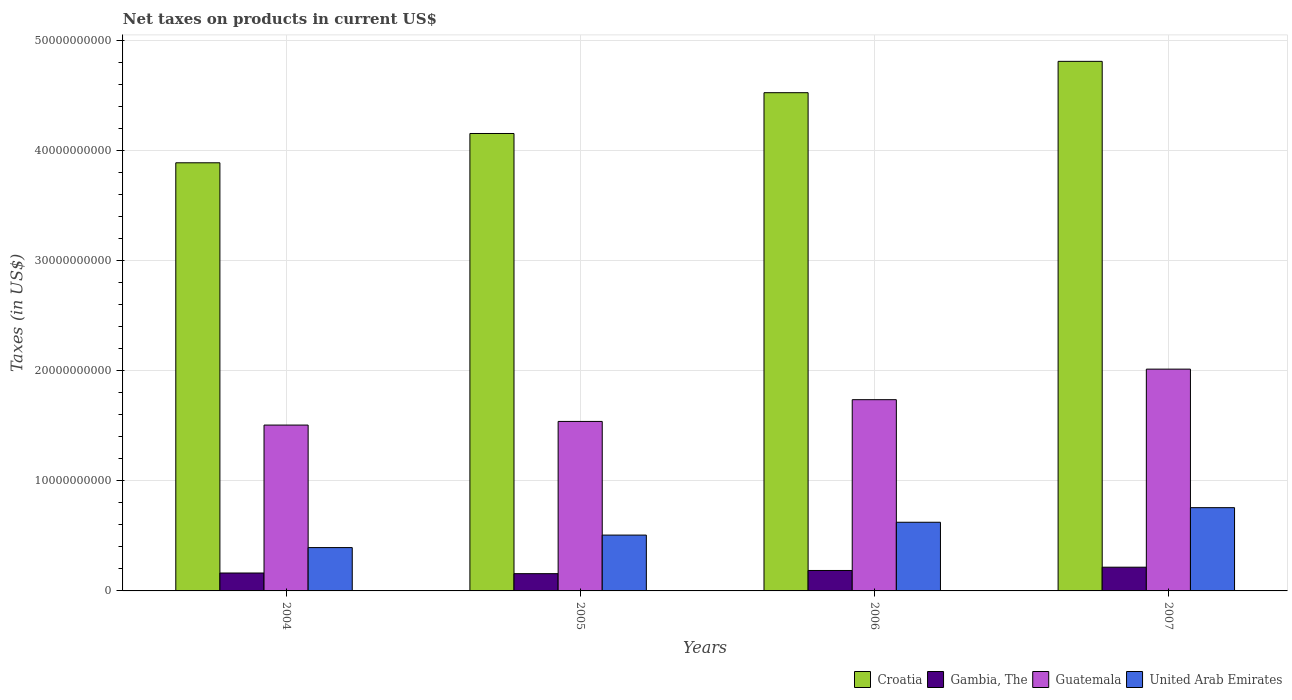How many groups of bars are there?
Offer a very short reply. 4. Are the number of bars per tick equal to the number of legend labels?
Keep it short and to the point. Yes. Are the number of bars on each tick of the X-axis equal?
Keep it short and to the point. Yes. How many bars are there on the 2nd tick from the right?
Provide a succinct answer. 4. What is the label of the 4th group of bars from the left?
Provide a short and direct response. 2007. In how many cases, is the number of bars for a given year not equal to the number of legend labels?
Make the answer very short. 0. What is the net taxes on products in Gambia, The in 2007?
Make the answer very short. 2.15e+09. Across all years, what is the maximum net taxes on products in Guatemala?
Make the answer very short. 2.01e+1. Across all years, what is the minimum net taxes on products in Croatia?
Offer a very short reply. 3.89e+1. In which year was the net taxes on products in Croatia maximum?
Your answer should be compact. 2007. What is the total net taxes on products in United Arab Emirates in the graph?
Keep it short and to the point. 2.28e+1. What is the difference between the net taxes on products in United Arab Emirates in 2004 and that in 2006?
Your answer should be compact. -2.30e+09. What is the difference between the net taxes on products in Croatia in 2006 and the net taxes on products in Guatemala in 2004?
Your answer should be compact. 3.02e+1. What is the average net taxes on products in United Arab Emirates per year?
Provide a short and direct response. 5.70e+09. In the year 2004, what is the difference between the net taxes on products in Croatia and net taxes on products in United Arab Emirates?
Your answer should be very brief. 3.49e+1. In how many years, is the net taxes on products in Croatia greater than 26000000000 US$?
Your answer should be very brief. 4. What is the ratio of the net taxes on products in United Arab Emirates in 2005 to that in 2007?
Keep it short and to the point. 0.67. Is the difference between the net taxes on products in Croatia in 2004 and 2007 greater than the difference between the net taxes on products in United Arab Emirates in 2004 and 2007?
Offer a very short reply. No. What is the difference between the highest and the second highest net taxes on products in United Arab Emirates?
Ensure brevity in your answer.  1.32e+09. What is the difference between the highest and the lowest net taxes on products in Croatia?
Provide a succinct answer. 9.21e+09. In how many years, is the net taxes on products in Guatemala greater than the average net taxes on products in Guatemala taken over all years?
Your answer should be compact. 2. What does the 2nd bar from the left in 2004 represents?
Provide a short and direct response. Gambia, The. What does the 2nd bar from the right in 2006 represents?
Your answer should be compact. Guatemala. Are all the bars in the graph horizontal?
Your response must be concise. No. What is the difference between two consecutive major ticks on the Y-axis?
Provide a succinct answer. 1.00e+1. Where does the legend appear in the graph?
Provide a succinct answer. Bottom right. How many legend labels are there?
Ensure brevity in your answer.  4. How are the legend labels stacked?
Ensure brevity in your answer.  Horizontal. What is the title of the graph?
Keep it short and to the point. Net taxes on products in current US$. Does "Argentina" appear as one of the legend labels in the graph?
Make the answer very short. No. What is the label or title of the Y-axis?
Offer a terse response. Taxes (in US$). What is the Taxes (in US$) in Croatia in 2004?
Provide a succinct answer. 3.89e+1. What is the Taxes (in US$) in Gambia, The in 2004?
Give a very brief answer. 1.63e+09. What is the Taxes (in US$) of Guatemala in 2004?
Make the answer very short. 1.51e+1. What is the Taxes (in US$) in United Arab Emirates in 2004?
Your answer should be very brief. 3.94e+09. What is the Taxes (in US$) of Croatia in 2005?
Offer a very short reply. 4.15e+1. What is the Taxes (in US$) of Gambia, The in 2005?
Make the answer very short. 1.57e+09. What is the Taxes (in US$) of Guatemala in 2005?
Offer a very short reply. 1.54e+1. What is the Taxes (in US$) in United Arab Emirates in 2005?
Provide a short and direct response. 5.07e+09. What is the Taxes (in US$) of Croatia in 2006?
Provide a short and direct response. 4.52e+1. What is the Taxes (in US$) in Gambia, The in 2006?
Provide a short and direct response. 1.86e+09. What is the Taxes (in US$) of Guatemala in 2006?
Offer a very short reply. 1.74e+1. What is the Taxes (in US$) in United Arab Emirates in 2006?
Offer a very short reply. 6.23e+09. What is the Taxes (in US$) in Croatia in 2007?
Your answer should be very brief. 4.81e+1. What is the Taxes (in US$) in Gambia, The in 2007?
Your response must be concise. 2.15e+09. What is the Taxes (in US$) of Guatemala in 2007?
Your answer should be compact. 2.01e+1. What is the Taxes (in US$) of United Arab Emirates in 2007?
Your answer should be compact. 7.56e+09. Across all years, what is the maximum Taxes (in US$) in Croatia?
Your answer should be very brief. 4.81e+1. Across all years, what is the maximum Taxes (in US$) in Gambia, The?
Offer a terse response. 2.15e+09. Across all years, what is the maximum Taxes (in US$) of Guatemala?
Provide a short and direct response. 2.01e+1. Across all years, what is the maximum Taxes (in US$) in United Arab Emirates?
Your answer should be compact. 7.56e+09. Across all years, what is the minimum Taxes (in US$) of Croatia?
Give a very brief answer. 3.89e+1. Across all years, what is the minimum Taxes (in US$) in Gambia, The?
Offer a terse response. 1.57e+09. Across all years, what is the minimum Taxes (in US$) of Guatemala?
Your answer should be very brief. 1.51e+1. Across all years, what is the minimum Taxes (in US$) of United Arab Emirates?
Your response must be concise. 3.94e+09. What is the total Taxes (in US$) of Croatia in the graph?
Keep it short and to the point. 1.74e+11. What is the total Taxes (in US$) of Gambia, The in the graph?
Your answer should be compact. 7.20e+09. What is the total Taxes (in US$) of Guatemala in the graph?
Provide a short and direct response. 6.79e+1. What is the total Taxes (in US$) of United Arab Emirates in the graph?
Make the answer very short. 2.28e+1. What is the difference between the Taxes (in US$) in Croatia in 2004 and that in 2005?
Provide a succinct answer. -2.66e+09. What is the difference between the Taxes (in US$) of Gambia, The in 2004 and that in 2005?
Your answer should be compact. 5.93e+07. What is the difference between the Taxes (in US$) of Guatemala in 2004 and that in 2005?
Make the answer very short. -3.31e+08. What is the difference between the Taxes (in US$) in United Arab Emirates in 2004 and that in 2005?
Ensure brevity in your answer.  -1.14e+09. What is the difference between the Taxes (in US$) of Croatia in 2004 and that in 2006?
Keep it short and to the point. -6.36e+09. What is the difference between the Taxes (in US$) in Gambia, The in 2004 and that in 2006?
Give a very brief answer. -2.30e+08. What is the difference between the Taxes (in US$) of Guatemala in 2004 and that in 2006?
Provide a short and direct response. -2.30e+09. What is the difference between the Taxes (in US$) in United Arab Emirates in 2004 and that in 2006?
Provide a short and direct response. -2.30e+09. What is the difference between the Taxes (in US$) of Croatia in 2004 and that in 2007?
Keep it short and to the point. -9.21e+09. What is the difference between the Taxes (in US$) of Gambia, The in 2004 and that in 2007?
Give a very brief answer. -5.28e+08. What is the difference between the Taxes (in US$) in Guatemala in 2004 and that in 2007?
Give a very brief answer. -5.08e+09. What is the difference between the Taxes (in US$) in United Arab Emirates in 2004 and that in 2007?
Offer a very short reply. -3.62e+09. What is the difference between the Taxes (in US$) of Croatia in 2005 and that in 2006?
Offer a terse response. -3.70e+09. What is the difference between the Taxes (in US$) of Gambia, The in 2005 and that in 2006?
Make the answer very short. -2.89e+08. What is the difference between the Taxes (in US$) in Guatemala in 2005 and that in 2006?
Give a very brief answer. -1.97e+09. What is the difference between the Taxes (in US$) of United Arab Emirates in 2005 and that in 2006?
Offer a very short reply. -1.16e+09. What is the difference between the Taxes (in US$) of Croatia in 2005 and that in 2007?
Your answer should be very brief. -6.55e+09. What is the difference between the Taxes (in US$) of Gambia, The in 2005 and that in 2007?
Provide a short and direct response. -5.87e+08. What is the difference between the Taxes (in US$) of Guatemala in 2005 and that in 2007?
Ensure brevity in your answer.  -4.75e+09. What is the difference between the Taxes (in US$) in United Arab Emirates in 2005 and that in 2007?
Your answer should be very brief. -2.49e+09. What is the difference between the Taxes (in US$) in Croatia in 2006 and that in 2007?
Your response must be concise. -2.85e+09. What is the difference between the Taxes (in US$) in Gambia, The in 2006 and that in 2007?
Provide a short and direct response. -2.98e+08. What is the difference between the Taxes (in US$) in Guatemala in 2006 and that in 2007?
Offer a terse response. -2.77e+09. What is the difference between the Taxes (in US$) in United Arab Emirates in 2006 and that in 2007?
Provide a succinct answer. -1.32e+09. What is the difference between the Taxes (in US$) in Croatia in 2004 and the Taxes (in US$) in Gambia, The in 2005?
Provide a short and direct response. 3.73e+1. What is the difference between the Taxes (in US$) in Croatia in 2004 and the Taxes (in US$) in Guatemala in 2005?
Offer a very short reply. 2.35e+1. What is the difference between the Taxes (in US$) of Croatia in 2004 and the Taxes (in US$) of United Arab Emirates in 2005?
Provide a short and direct response. 3.38e+1. What is the difference between the Taxes (in US$) in Gambia, The in 2004 and the Taxes (in US$) in Guatemala in 2005?
Your answer should be compact. -1.38e+1. What is the difference between the Taxes (in US$) in Gambia, The in 2004 and the Taxes (in US$) in United Arab Emirates in 2005?
Your answer should be compact. -3.44e+09. What is the difference between the Taxes (in US$) of Guatemala in 2004 and the Taxes (in US$) of United Arab Emirates in 2005?
Keep it short and to the point. 9.99e+09. What is the difference between the Taxes (in US$) of Croatia in 2004 and the Taxes (in US$) of Gambia, The in 2006?
Keep it short and to the point. 3.70e+1. What is the difference between the Taxes (in US$) of Croatia in 2004 and the Taxes (in US$) of Guatemala in 2006?
Give a very brief answer. 2.15e+1. What is the difference between the Taxes (in US$) in Croatia in 2004 and the Taxes (in US$) in United Arab Emirates in 2006?
Provide a succinct answer. 3.26e+1. What is the difference between the Taxes (in US$) of Gambia, The in 2004 and the Taxes (in US$) of Guatemala in 2006?
Provide a short and direct response. -1.57e+1. What is the difference between the Taxes (in US$) in Gambia, The in 2004 and the Taxes (in US$) in United Arab Emirates in 2006?
Your answer should be compact. -4.61e+09. What is the difference between the Taxes (in US$) in Guatemala in 2004 and the Taxes (in US$) in United Arab Emirates in 2006?
Offer a very short reply. 8.82e+09. What is the difference between the Taxes (in US$) in Croatia in 2004 and the Taxes (in US$) in Gambia, The in 2007?
Your response must be concise. 3.67e+1. What is the difference between the Taxes (in US$) in Croatia in 2004 and the Taxes (in US$) in Guatemala in 2007?
Make the answer very short. 1.87e+1. What is the difference between the Taxes (in US$) in Croatia in 2004 and the Taxes (in US$) in United Arab Emirates in 2007?
Give a very brief answer. 3.13e+1. What is the difference between the Taxes (in US$) in Gambia, The in 2004 and the Taxes (in US$) in Guatemala in 2007?
Ensure brevity in your answer.  -1.85e+1. What is the difference between the Taxes (in US$) of Gambia, The in 2004 and the Taxes (in US$) of United Arab Emirates in 2007?
Provide a succinct answer. -5.93e+09. What is the difference between the Taxes (in US$) in Guatemala in 2004 and the Taxes (in US$) in United Arab Emirates in 2007?
Your answer should be compact. 7.50e+09. What is the difference between the Taxes (in US$) of Croatia in 2005 and the Taxes (in US$) of Gambia, The in 2006?
Offer a terse response. 3.97e+1. What is the difference between the Taxes (in US$) of Croatia in 2005 and the Taxes (in US$) of Guatemala in 2006?
Provide a short and direct response. 2.42e+1. What is the difference between the Taxes (in US$) in Croatia in 2005 and the Taxes (in US$) in United Arab Emirates in 2006?
Your answer should be compact. 3.53e+1. What is the difference between the Taxes (in US$) in Gambia, The in 2005 and the Taxes (in US$) in Guatemala in 2006?
Your answer should be very brief. -1.58e+1. What is the difference between the Taxes (in US$) in Gambia, The in 2005 and the Taxes (in US$) in United Arab Emirates in 2006?
Keep it short and to the point. -4.67e+09. What is the difference between the Taxes (in US$) of Guatemala in 2005 and the Taxes (in US$) of United Arab Emirates in 2006?
Offer a terse response. 9.16e+09. What is the difference between the Taxes (in US$) in Croatia in 2005 and the Taxes (in US$) in Gambia, The in 2007?
Keep it short and to the point. 3.94e+1. What is the difference between the Taxes (in US$) of Croatia in 2005 and the Taxes (in US$) of Guatemala in 2007?
Provide a short and direct response. 2.14e+1. What is the difference between the Taxes (in US$) of Croatia in 2005 and the Taxes (in US$) of United Arab Emirates in 2007?
Make the answer very short. 3.40e+1. What is the difference between the Taxes (in US$) in Gambia, The in 2005 and the Taxes (in US$) in Guatemala in 2007?
Your response must be concise. -1.86e+1. What is the difference between the Taxes (in US$) in Gambia, The in 2005 and the Taxes (in US$) in United Arab Emirates in 2007?
Keep it short and to the point. -5.99e+09. What is the difference between the Taxes (in US$) in Guatemala in 2005 and the Taxes (in US$) in United Arab Emirates in 2007?
Provide a short and direct response. 7.83e+09. What is the difference between the Taxes (in US$) in Croatia in 2006 and the Taxes (in US$) in Gambia, The in 2007?
Keep it short and to the point. 4.31e+1. What is the difference between the Taxes (in US$) in Croatia in 2006 and the Taxes (in US$) in Guatemala in 2007?
Give a very brief answer. 2.51e+1. What is the difference between the Taxes (in US$) of Croatia in 2006 and the Taxes (in US$) of United Arab Emirates in 2007?
Offer a very short reply. 3.77e+1. What is the difference between the Taxes (in US$) in Gambia, The in 2006 and the Taxes (in US$) in Guatemala in 2007?
Ensure brevity in your answer.  -1.83e+1. What is the difference between the Taxes (in US$) in Gambia, The in 2006 and the Taxes (in US$) in United Arab Emirates in 2007?
Offer a terse response. -5.70e+09. What is the difference between the Taxes (in US$) of Guatemala in 2006 and the Taxes (in US$) of United Arab Emirates in 2007?
Provide a short and direct response. 9.80e+09. What is the average Taxes (in US$) of Croatia per year?
Keep it short and to the point. 4.34e+1. What is the average Taxes (in US$) of Gambia, The per year?
Provide a succinct answer. 1.80e+09. What is the average Taxes (in US$) in Guatemala per year?
Keep it short and to the point. 1.70e+1. What is the average Taxes (in US$) in United Arab Emirates per year?
Offer a terse response. 5.70e+09. In the year 2004, what is the difference between the Taxes (in US$) of Croatia and Taxes (in US$) of Gambia, The?
Make the answer very short. 3.72e+1. In the year 2004, what is the difference between the Taxes (in US$) in Croatia and Taxes (in US$) in Guatemala?
Your response must be concise. 2.38e+1. In the year 2004, what is the difference between the Taxes (in US$) in Croatia and Taxes (in US$) in United Arab Emirates?
Your answer should be compact. 3.49e+1. In the year 2004, what is the difference between the Taxes (in US$) of Gambia, The and Taxes (in US$) of Guatemala?
Offer a very short reply. -1.34e+1. In the year 2004, what is the difference between the Taxes (in US$) in Gambia, The and Taxes (in US$) in United Arab Emirates?
Provide a short and direct response. -2.31e+09. In the year 2004, what is the difference between the Taxes (in US$) of Guatemala and Taxes (in US$) of United Arab Emirates?
Your answer should be compact. 1.11e+1. In the year 2005, what is the difference between the Taxes (in US$) in Croatia and Taxes (in US$) in Gambia, The?
Make the answer very short. 4.00e+1. In the year 2005, what is the difference between the Taxes (in US$) in Croatia and Taxes (in US$) in Guatemala?
Make the answer very short. 2.61e+1. In the year 2005, what is the difference between the Taxes (in US$) of Croatia and Taxes (in US$) of United Arab Emirates?
Make the answer very short. 3.65e+1. In the year 2005, what is the difference between the Taxes (in US$) of Gambia, The and Taxes (in US$) of Guatemala?
Offer a terse response. -1.38e+1. In the year 2005, what is the difference between the Taxes (in US$) in Gambia, The and Taxes (in US$) in United Arab Emirates?
Keep it short and to the point. -3.50e+09. In the year 2005, what is the difference between the Taxes (in US$) in Guatemala and Taxes (in US$) in United Arab Emirates?
Your answer should be compact. 1.03e+1. In the year 2006, what is the difference between the Taxes (in US$) in Croatia and Taxes (in US$) in Gambia, The?
Your answer should be very brief. 4.34e+1. In the year 2006, what is the difference between the Taxes (in US$) in Croatia and Taxes (in US$) in Guatemala?
Your answer should be very brief. 2.79e+1. In the year 2006, what is the difference between the Taxes (in US$) of Croatia and Taxes (in US$) of United Arab Emirates?
Make the answer very short. 3.90e+1. In the year 2006, what is the difference between the Taxes (in US$) of Gambia, The and Taxes (in US$) of Guatemala?
Provide a short and direct response. -1.55e+1. In the year 2006, what is the difference between the Taxes (in US$) in Gambia, The and Taxes (in US$) in United Arab Emirates?
Offer a very short reply. -4.38e+09. In the year 2006, what is the difference between the Taxes (in US$) of Guatemala and Taxes (in US$) of United Arab Emirates?
Provide a succinct answer. 1.11e+1. In the year 2007, what is the difference between the Taxes (in US$) of Croatia and Taxes (in US$) of Gambia, The?
Give a very brief answer. 4.59e+1. In the year 2007, what is the difference between the Taxes (in US$) in Croatia and Taxes (in US$) in Guatemala?
Offer a very short reply. 2.79e+1. In the year 2007, what is the difference between the Taxes (in US$) of Croatia and Taxes (in US$) of United Arab Emirates?
Offer a terse response. 4.05e+1. In the year 2007, what is the difference between the Taxes (in US$) of Gambia, The and Taxes (in US$) of Guatemala?
Ensure brevity in your answer.  -1.80e+1. In the year 2007, what is the difference between the Taxes (in US$) of Gambia, The and Taxes (in US$) of United Arab Emirates?
Your response must be concise. -5.40e+09. In the year 2007, what is the difference between the Taxes (in US$) of Guatemala and Taxes (in US$) of United Arab Emirates?
Provide a short and direct response. 1.26e+1. What is the ratio of the Taxes (in US$) of Croatia in 2004 to that in 2005?
Your answer should be very brief. 0.94. What is the ratio of the Taxes (in US$) in Gambia, The in 2004 to that in 2005?
Keep it short and to the point. 1.04. What is the ratio of the Taxes (in US$) in Guatemala in 2004 to that in 2005?
Offer a very short reply. 0.98. What is the ratio of the Taxes (in US$) of United Arab Emirates in 2004 to that in 2005?
Offer a terse response. 0.78. What is the ratio of the Taxes (in US$) of Croatia in 2004 to that in 2006?
Your answer should be compact. 0.86. What is the ratio of the Taxes (in US$) in Gambia, The in 2004 to that in 2006?
Ensure brevity in your answer.  0.88. What is the ratio of the Taxes (in US$) of Guatemala in 2004 to that in 2006?
Your response must be concise. 0.87. What is the ratio of the Taxes (in US$) in United Arab Emirates in 2004 to that in 2006?
Your answer should be very brief. 0.63. What is the ratio of the Taxes (in US$) in Croatia in 2004 to that in 2007?
Your answer should be compact. 0.81. What is the ratio of the Taxes (in US$) in Gambia, The in 2004 to that in 2007?
Keep it short and to the point. 0.76. What is the ratio of the Taxes (in US$) in Guatemala in 2004 to that in 2007?
Provide a short and direct response. 0.75. What is the ratio of the Taxes (in US$) of United Arab Emirates in 2004 to that in 2007?
Your response must be concise. 0.52. What is the ratio of the Taxes (in US$) of Croatia in 2005 to that in 2006?
Your answer should be compact. 0.92. What is the ratio of the Taxes (in US$) of Gambia, The in 2005 to that in 2006?
Give a very brief answer. 0.84. What is the ratio of the Taxes (in US$) of Guatemala in 2005 to that in 2006?
Keep it short and to the point. 0.89. What is the ratio of the Taxes (in US$) of United Arab Emirates in 2005 to that in 2006?
Provide a succinct answer. 0.81. What is the ratio of the Taxes (in US$) of Croatia in 2005 to that in 2007?
Give a very brief answer. 0.86. What is the ratio of the Taxes (in US$) in Gambia, The in 2005 to that in 2007?
Your response must be concise. 0.73. What is the ratio of the Taxes (in US$) in Guatemala in 2005 to that in 2007?
Offer a terse response. 0.76. What is the ratio of the Taxes (in US$) of United Arab Emirates in 2005 to that in 2007?
Offer a terse response. 0.67. What is the ratio of the Taxes (in US$) in Croatia in 2006 to that in 2007?
Give a very brief answer. 0.94. What is the ratio of the Taxes (in US$) of Gambia, The in 2006 to that in 2007?
Make the answer very short. 0.86. What is the ratio of the Taxes (in US$) of Guatemala in 2006 to that in 2007?
Ensure brevity in your answer.  0.86. What is the ratio of the Taxes (in US$) of United Arab Emirates in 2006 to that in 2007?
Offer a terse response. 0.82. What is the difference between the highest and the second highest Taxes (in US$) in Croatia?
Make the answer very short. 2.85e+09. What is the difference between the highest and the second highest Taxes (in US$) in Gambia, The?
Make the answer very short. 2.98e+08. What is the difference between the highest and the second highest Taxes (in US$) in Guatemala?
Give a very brief answer. 2.77e+09. What is the difference between the highest and the second highest Taxes (in US$) in United Arab Emirates?
Offer a terse response. 1.32e+09. What is the difference between the highest and the lowest Taxes (in US$) in Croatia?
Your answer should be compact. 9.21e+09. What is the difference between the highest and the lowest Taxes (in US$) of Gambia, The?
Offer a very short reply. 5.87e+08. What is the difference between the highest and the lowest Taxes (in US$) in Guatemala?
Your answer should be compact. 5.08e+09. What is the difference between the highest and the lowest Taxes (in US$) of United Arab Emirates?
Your response must be concise. 3.62e+09. 